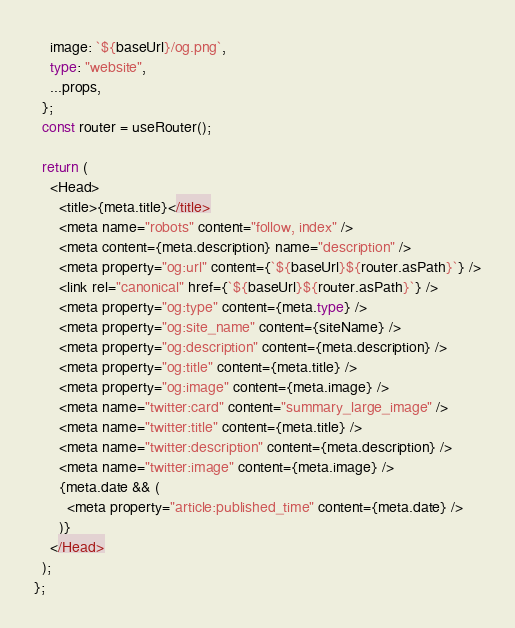<code> <loc_0><loc_0><loc_500><loc_500><_TypeScript_>    image: `${baseUrl}/og.png`,
    type: "website",
    ...props,
  };
  const router = useRouter();

  return (
    <Head>
      <title>{meta.title}</title>
      <meta name="robots" content="follow, index" />
      <meta content={meta.description} name="description" />
      <meta property="og:url" content={`${baseUrl}${router.asPath}`} />
      <link rel="canonical" href={`${baseUrl}${router.asPath}`} />
      <meta property="og:type" content={meta.type} />
      <meta property="og:site_name" content={siteName} />
      <meta property="og:description" content={meta.description} />
      <meta property="og:title" content={meta.title} />
      <meta property="og:image" content={meta.image} />
      <meta name="twitter:card" content="summary_large_image" />
      <meta name="twitter:title" content={meta.title} />
      <meta name="twitter:description" content={meta.description} />
      <meta name="twitter:image" content={meta.image} />
      {meta.date && (
        <meta property="article:published_time" content={meta.date} />
      )}
    </Head>
  );
};
</code> 